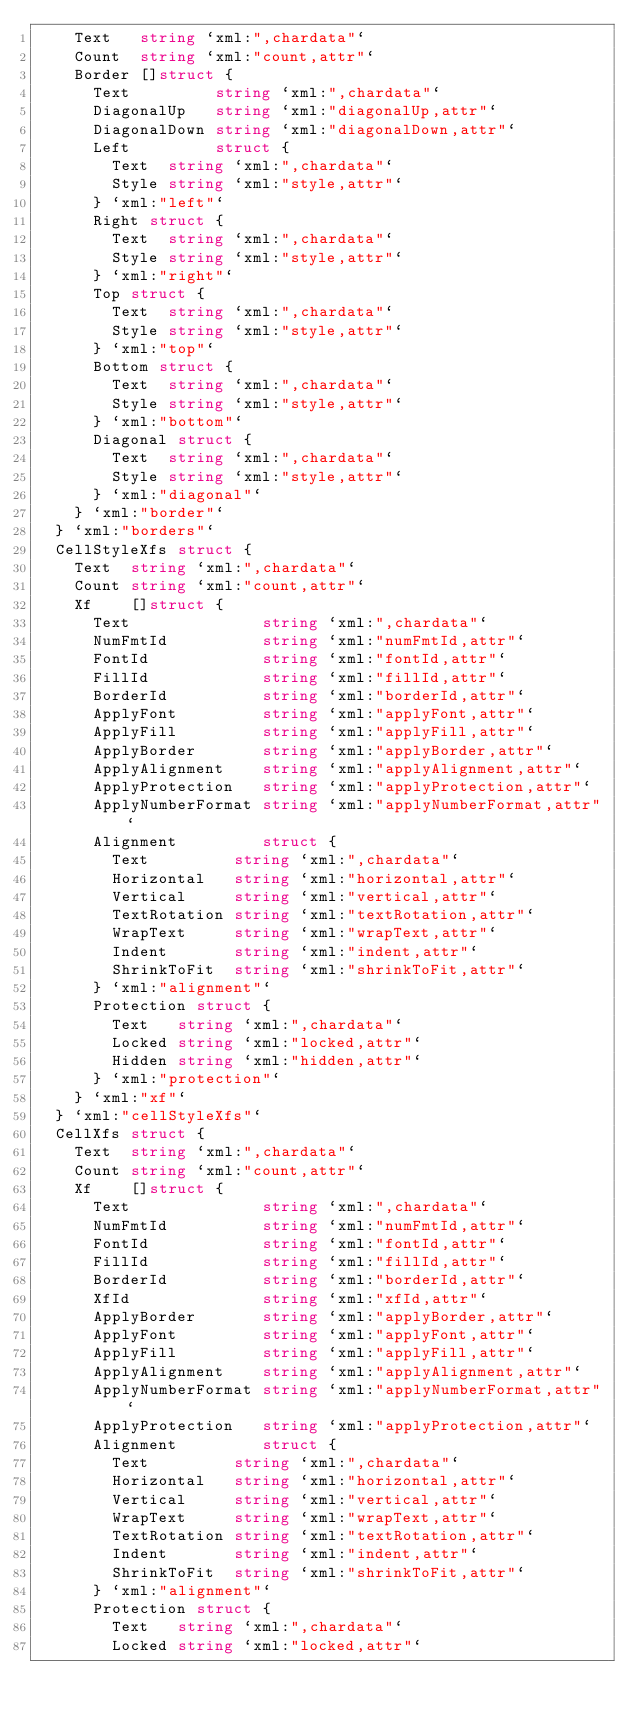<code> <loc_0><loc_0><loc_500><loc_500><_Go_>		Text   string `xml:",chardata"`
		Count  string `xml:"count,attr"`
		Border []struct {
			Text         string `xml:",chardata"`
			DiagonalUp   string `xml:"diagonalUp,attr"`
			DiagonalDown string `xml:"diagonalDown,attr"`
			Left         struct {
				Text  string `xml:",chardata"`
				Style string `xml:"style,attr"`
			} `xml:"left"`
			Right struct {
				Text  string `xml:",chardata"`
				Style string `xml:"style,attr"`
			} `xml:"right"`
			Top struct {
				Text  string `xml:",chardata"`
				Style string `xml:"style,attr"`
			} `xml:"top"`
			Bottom struct {
				Text  string `xml:",chardata"`
				Style string `xml:"style,attr"`
			} `xml:"bottom"`
			Diagonal struct {
				Text  string `xml:",chardata"`
				Style string `xml:"style,attr"`
			} `xml:"diagonal"`
		} `xml:"border"`
	} `xml:"borders"`
	CellStyleXfs struct {
		Text  string `xml:",chardata"`
		Count string `xml:"count,attr"`
		Xf    []struct {
			Text              string `xml:",chardata"`
			NumFmtId          string `xml:"numFmtId,attr"`
			FontId            string `xml:"fontId,attr"`
			FillId            string `xml:"fillId,attr"`
			BorderId          string `xml:"borderId,attr"`
			ApplyFont         string `xml:"applyFont,attr"`
			ApplyFill         string `xml:"applyFill,attr"`
			ApplyBorder       string `xml:"applyBorder,attr"`
			ApplyAlignment    string `xml:"applyAlignment,attr"`
			ApplyProtection   string `xml:"applyProtection,attr"`
			ApplyNumberFormat string `xml:"applyNumberFormat,attr"`
			Alignment         struct {
				Text         string `xml:",chardata"`
				Horizontal   string `xml:"horizontal,attr"`
				Vertical     string `xml:"vertical,attr"`
				TextRotation string `xml:"textRotation,attr"`
				WrapText     string `xml:"wrapText,attr"`
				Indent       string `xml:"indent,attr"`
				ShrinkToFit  string `xml:"shrinkToFit,attr"`
			} `xml:"alignment"`
			Protection struct {
				Text   string `xml:",chardata"`
				Locked string `xml:"locked,attr"`
				Hidden string `xml:"hidden,attr"`
			} `xml:"protection"`
		} `xml:"xf"`
	} `xml:"cellStyleXfs"`
	CellXfs struct {
		Text  string `xml:",chardata"`
		Count string `xml:"count,attr"`
		Xf    []struct {
			Text              string `xml:",chardata"`
			NumFmtId          string `xml:"numFmtId,attr"`
			FontId            string `xml:"fontId,attr"`
			FillId            string `xml:"fillId,attr"`
			BorderId          string `xml:"borderId,attr"`
			XfId              string `xml:"xfId,attr"`
			ApplyBorder       string `xml:"applyBorder,attr"`
			ApplyFont         string `xml:"applyFont,attr"`
			ApplyFill         string `xml:"applyFill,attr"`
			ApplyAlignment    string `xml:"applyAlignment,attr"`
			ApplyNumberFormat string `xml:"applyNumberFormat,attr"`
			ApplyProtection   string `xml:"applyProtection,attr"`
			Alignment         struct {
				Text         string `xml:",chardata"`
				Horizontal   string `xml:"horizontal,attr"`
				Vertical     string `xml:"vertical,attr"`
				WrapText     string `xml:"wrapText,attr"`
				TextRotation string `xml:"textRotation,attr"`
				Indent       string `xml:"indent,attr"`
				ShrinkToFit  string `xml:"shrinkToFit,attr"`
			} `xml:"alignment"`
			Protection struct {
				Text   string `xml:",chardata"`
				Locked string `xml:"locked,attr"`</code> 